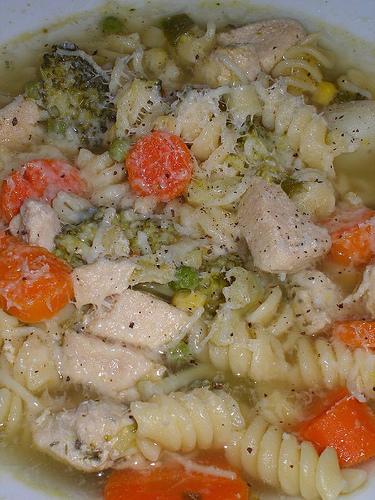Can you have this with rice?
Be succinct. Yes. What shape of pasta is used in this dish?
Short answer required. Spiral. What kind of soup is this?
Quick response, please. Chicken noodle. What veggies are in this dish?
Write a very short answer. Carrots. What type of meat do you see?
Quick response, please. Chicken. Is this gluten free?
Concise answer only. No. Is there meat in this soup?
Quick response, please. Yes. Have you ever made such a pasta dish?
Keep it brief. No. 